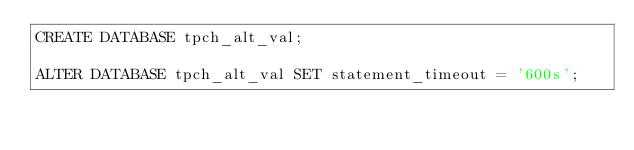<code> <loc_0><loc_0><loc_500><loc_500><_SQL_>CREATE DATABASE tpch_alt_val;

ALTER DATABASE tpch_alt_val SET statement_timeout = '600s';</code> 